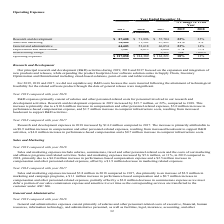Looking at Manhattan Associates's financial data, please calculate: What is the change in research and development cost between 2019 and 2018? Based on the calculation: $87,608-$71,896, the result is 15712 (in thousands). This is based on the information: "Research and development $ 87,608 $ 71,896 $ 57,704 22% 25% Research and development $ 87,608 $ 71,896 $ 57,704 22% 25%..." The key data points involved are: 71,896, 87,608. Additionally, Which year has a higher Sales and Marketing expense? According to the financial document, 2019. The relevant text states: "2019 2018 2017 2019 2018..." Also, can you calculate: What is the change in depreciation and amortization cost between 2019 and 2018? Based on the calculation: $8,613-7,987, the result is 626 (in thousands). This is based on the information: "Depreciation and amortization 7,987 8,613 9,060 -7% -5% Depreciation and amortization 7,987 8,613 9,060 -7% -5%..." The key data points involved are: 7,987, 8,613. Also, How many positions are eliminated in 2017 May? Based on the financial document, the answer is about 100. Also, What is the research and development expense in 2019? According to the financial document, $ 87,608 (in thousands). The relevant text states: "Research and development $ 87,608 $ 71,896 $ 57,704 22% 25%..." Also, What is the sales and marketing expense increase in 2018 from 2017? According to the financial document, $3.8 million. The relevant text states: "Sales and marketing expenses increased $3.8 million in 2018 compared to 2017, due primarily to an increase of $2.9 million in marketing and campaign pro Sales and marketing expenses increased $3.8 mil..." 